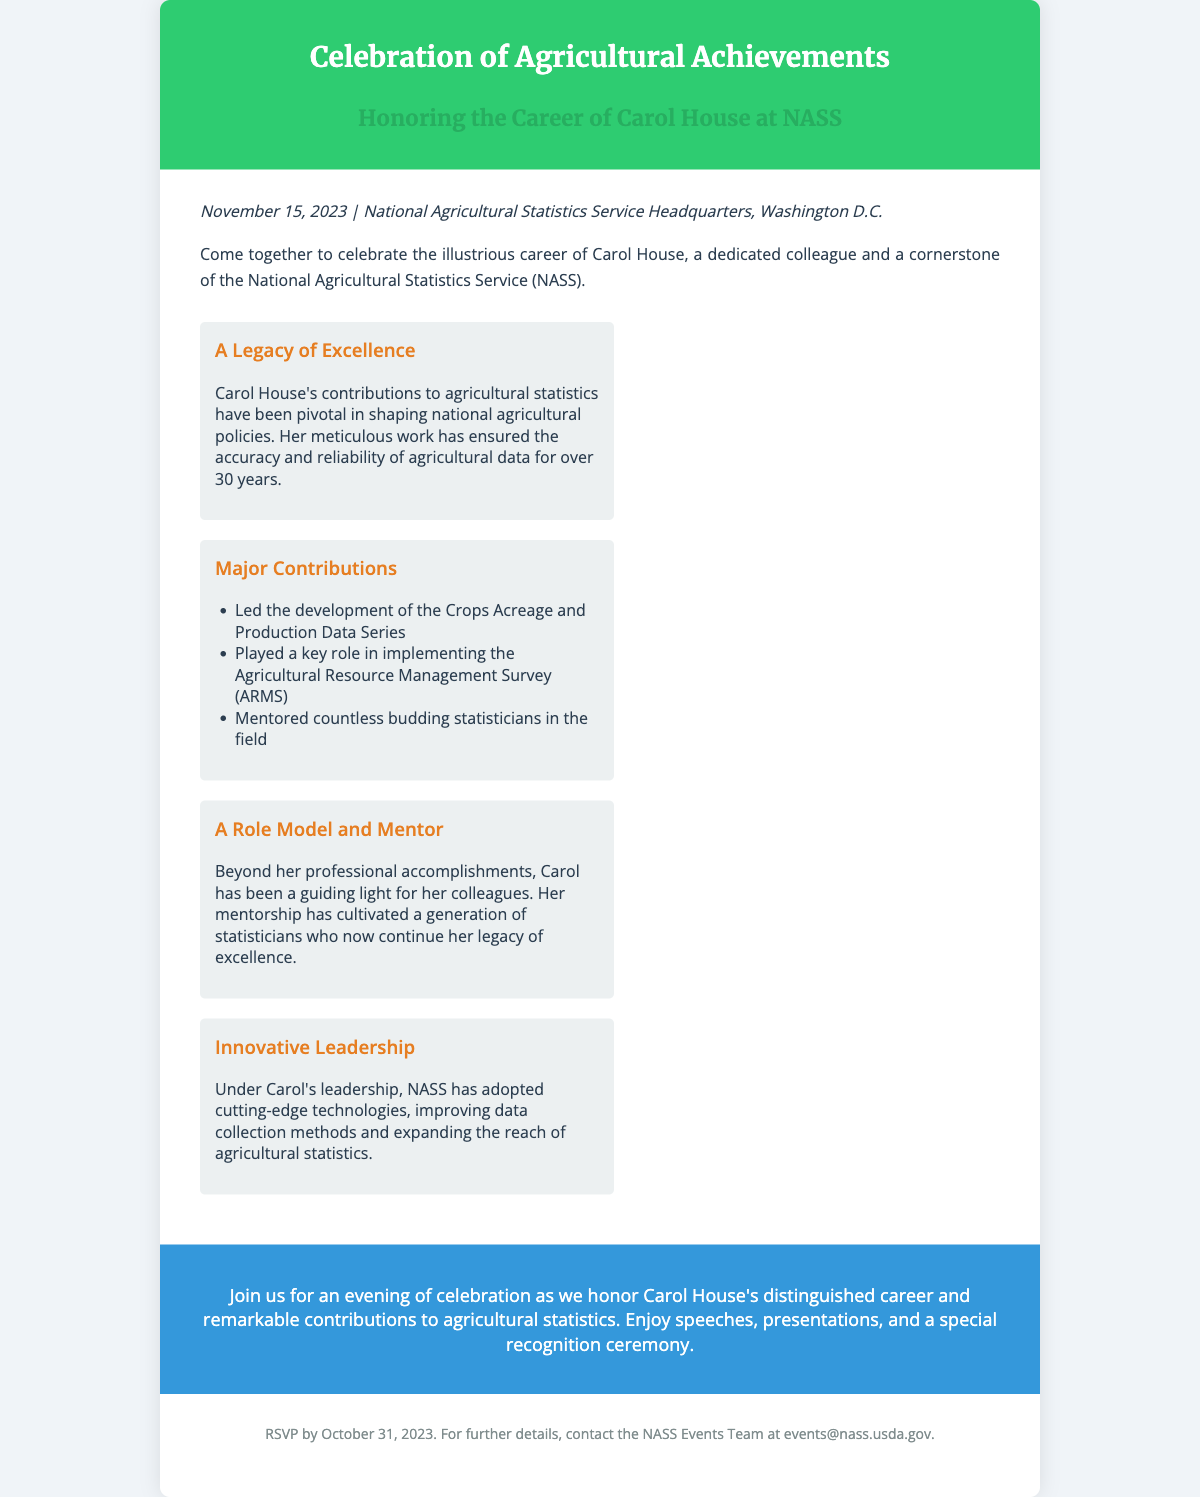What is the date of the event? The date of the event is explicitly stated in the document as November 15, 2023.
Answer: November 15, 2023 Where will the event take place? The venue for the event is mentioned in the document as the National Agricultural Statistics Service Headquarters, Washington D.C.
Answer: National Agricultural Statistics Service Headquarters, Washington D.C Who is being honored at the event? The flyer specifies that Carol House is the individual being honored for her career at NASS.
Answer: Carol House How many years of contributions does Carol House have at NASS? The document mentions that Carol House has contributed for over 30 years.
Answer: over 30 years What is one of Carol House's major contributions? The document lists several contributions, one of which is leading the development of the Crops Acreage and Production Data Series.
Answer: Led the development of the Crops Acreage and Production Data Series What type of experience does Carol provide beyond her professional work? The flyer highlights that Carol has been a mentor, guiding many budding statisticians.
Answer: Mentor What should attendees do by October 31, 2023? The RSVP deadline is clearly stated in the document as October 31, 2023.
Answer: RSVP What will the celebration include? The flyer indicates that attendees can expect speeches, presentations, and a special recognition ceremony.
Answer: Speeches, presentations, and a special recognition ceremony What color is associated with the header of the flyer? The header color of the flyer is specified as green in the styling section.
Answer: Green 